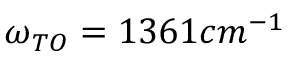<formula> <loc_0><loc_0><loc_500><loc_500>\omega _ { T O } = 1 3 6 1 c m ^ { - 1 }</formula> 